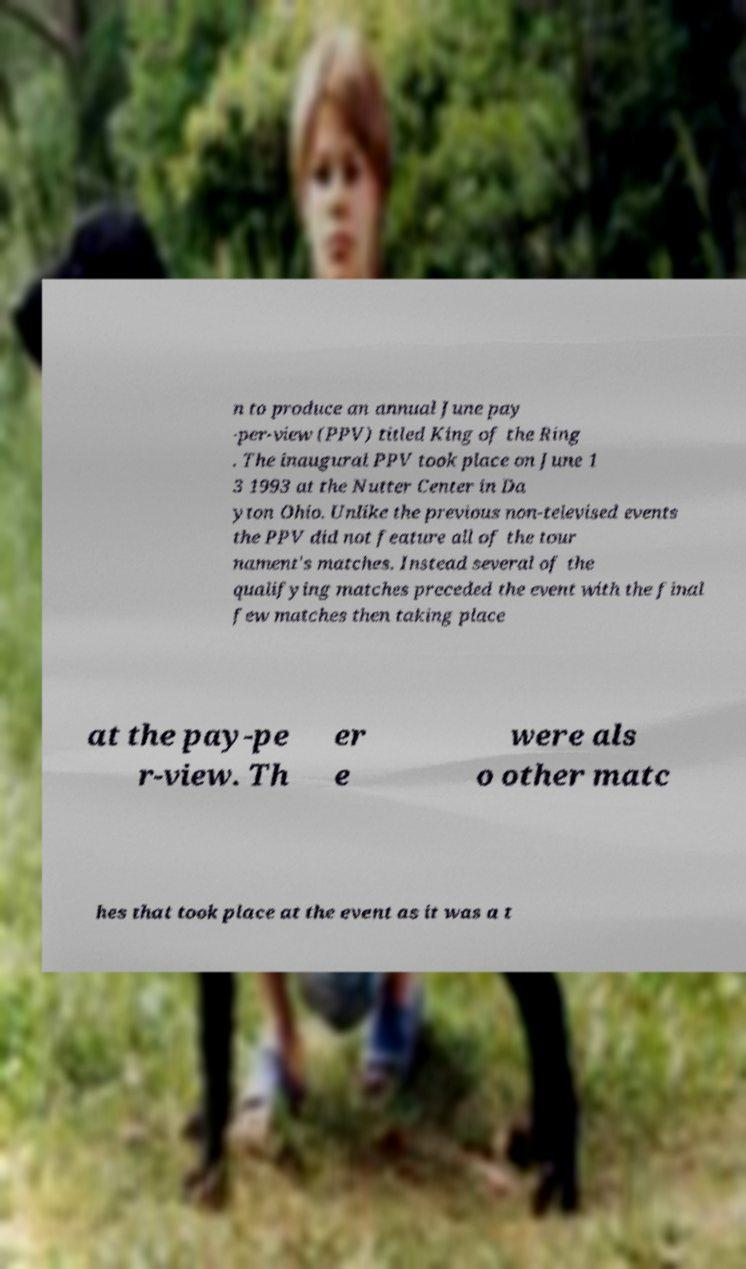Can you read and provide the text displayed in the image?This photo seems to have some interesting text. Can you extract and type it out for me? n to produce an annual June pay -per-view (PPV) titled King of the Ring . The inaugural PPV took place on June 1 3 1993 at the Nutter Center in Da yton Ohio. Unlike the previous non-televised events the PPV did not feature all of the tour nament's matches. Instead several of the qualifying matches preceded the event with the final few matches then taking place at the pay-pe r-view. Th er e were als o other matc hes that took place at the event as it was a t 